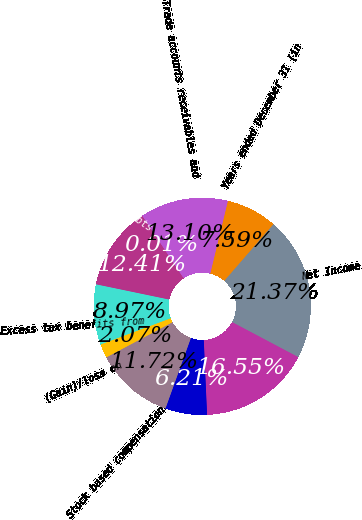Convert chart to OTSL. <chart><loc_0><loc_0><loc_500><loc_500><pie_chart><fcel>Years ended December 31 (in<fcel>Net Income<fcel>Depreciation and amortization<fcel>Provision for deferred income<fcel>Stock based compensation<fcel>(Gain)/loss on<fcel>Excess tax benefits from<fcel>Provision for bad debts<fcel>Other net<fcel>Trade accounts receivables and<nl><fcel>7.59%<fcel>21.37%<fcel>16.55%<fcel>6.21%<fcel>11.72%<fcel>2.07%<fcel>8.97%<fcel>12.41%<fcel>0.01%<fcel>13.1%<nl></chart> 